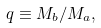<formula> <loc_0><loc_0><loc_500><loc_500>q \equiv M _ { b } / M _ { a } ,</formula> 